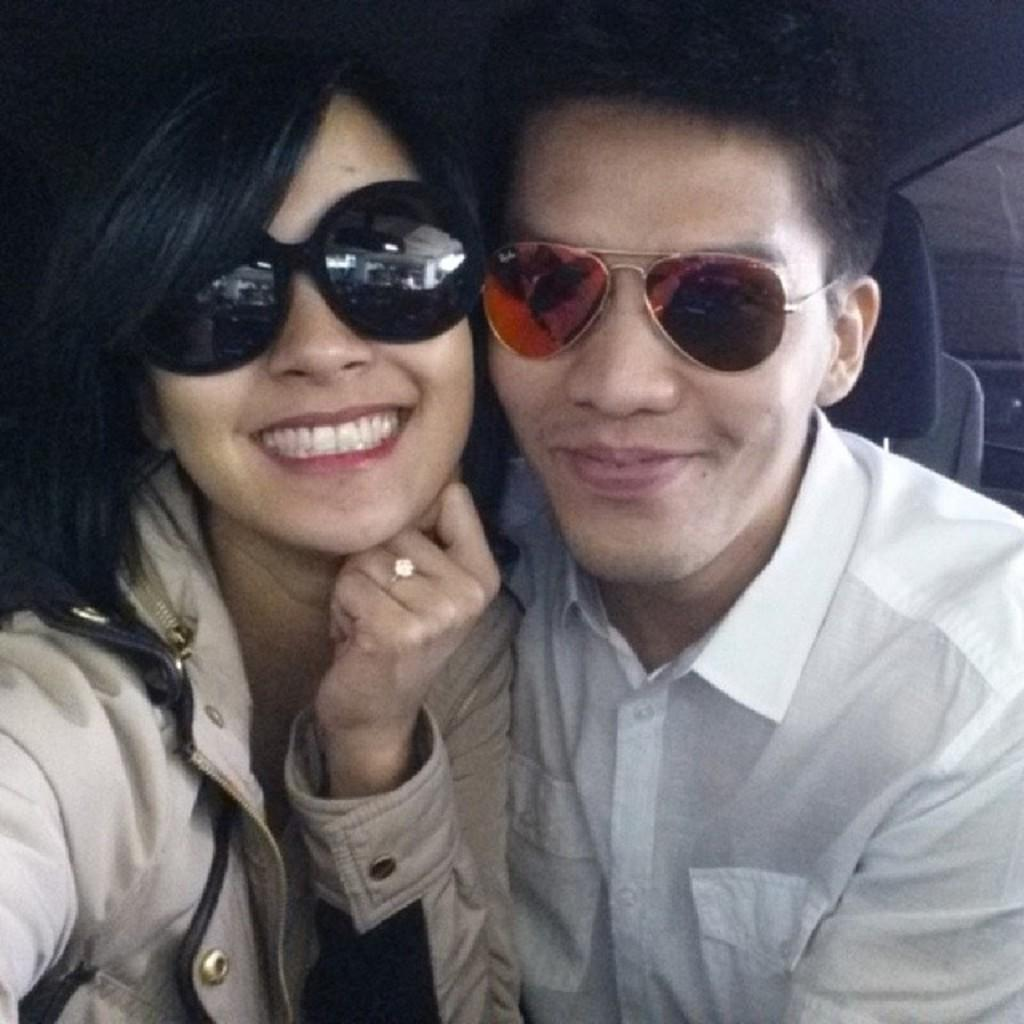How many people are in the image? There are two people in the image. What are the people wearing? Both people are wearing glasses. What expression do the people have? Both people are smiling. What can be observed about the background of the image? The background of the image is dark. What reason does the servant have for being in the image? There is no servant present in the image, so it is not possible to determine a reason for their presence. 